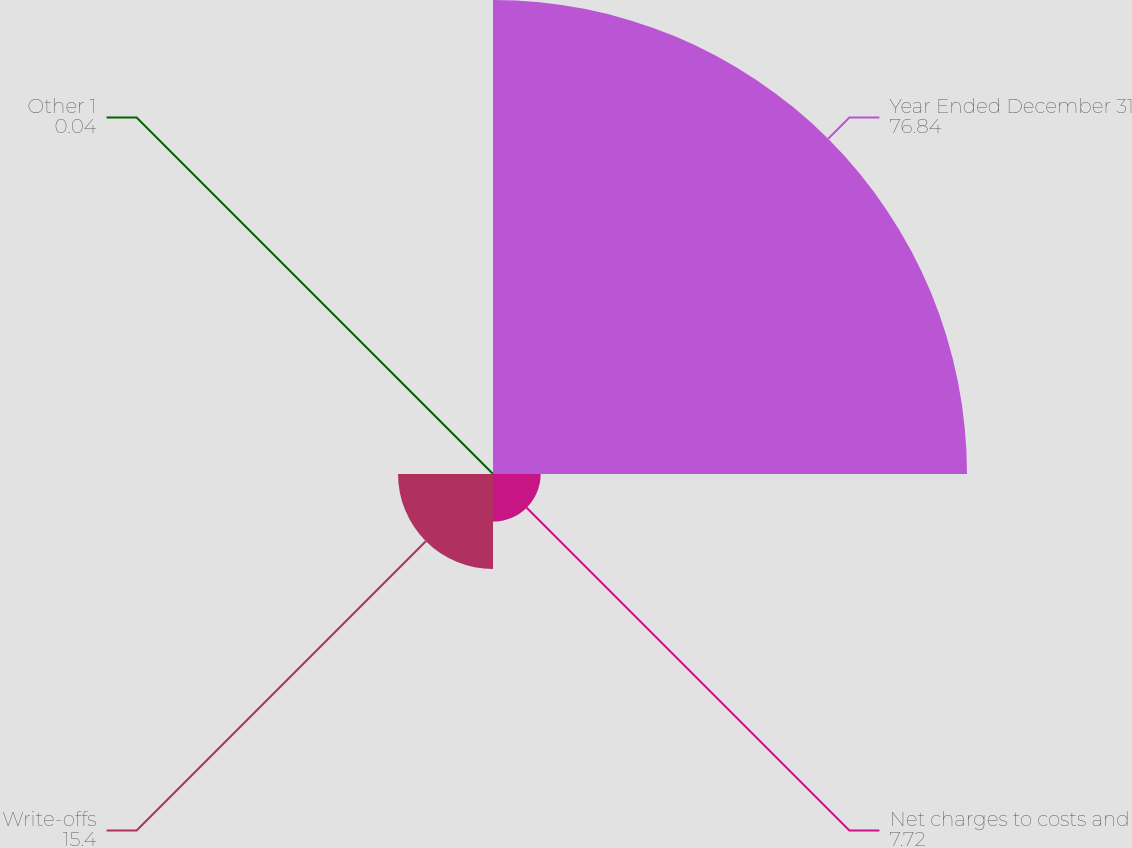<chart> <loc_0><loc_0><loc_500><loc_500><pie_chart><fcel>Year Ended December 31<fcel>Net charges to costs and<fcel>Write-offs<fcel>Other 1<nl><fcel>76.84%<fcel>7.72%<fcel>15.4%<fcel>0.04%<nl></chart> 